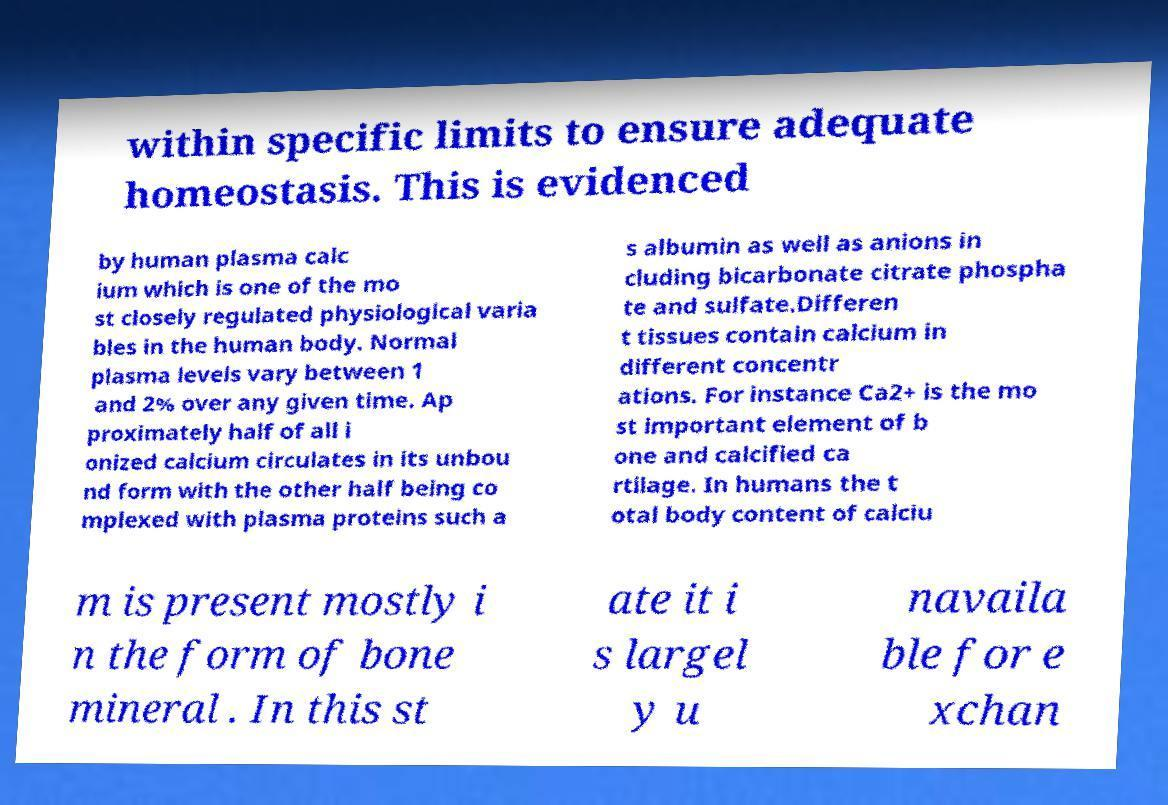Could you extract and type out the text from this image? within specific limits to ensure adequate homeostasis. This is evidenced by human plasma calc ium which is one of the mo st closely regulated physiological varia bles in the human body. Normal plasma levels vary between 1 and 2% over any given time. Ap proximately half of all i onized calcium circulates in its unbou nd form with the other half being co mplexed with plasma proteins such a s albumin as well as anions in cluding bicarbonate citrate phospha te and sulfate.Differen t tissues contain calcium in different concentr ations. For instance Ca2+ is the mo st important element of b one and calcified ca rtilage. In humans the t otal body content of calciu m is present mostly i n the form of bone mineral . In this st ate it i s largel y u navaila ble for e xchan 